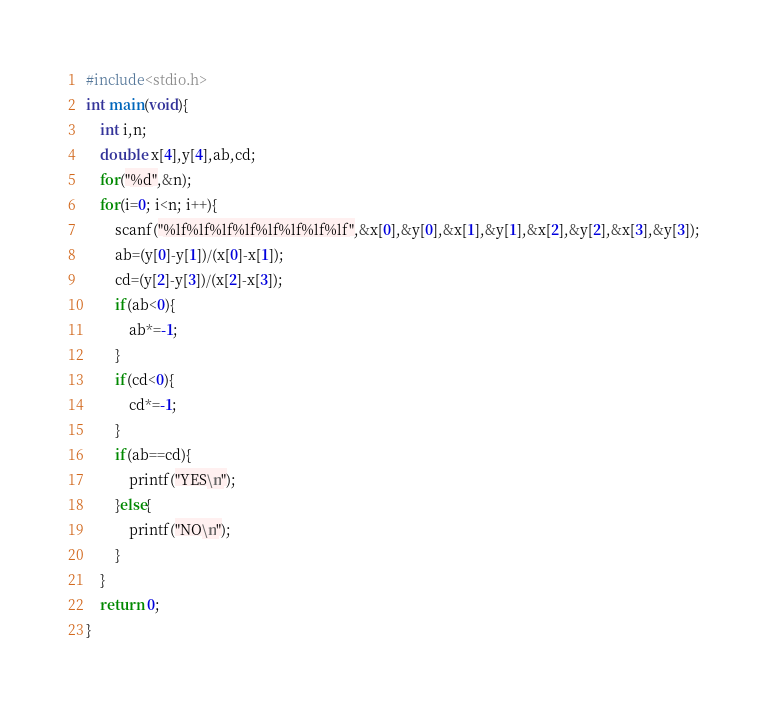Convert code to text. <code><loc_0><loc_0><loc_500><loc_500><_C_>#include<stdio.h>
int main(void){
    int i,n;
    double x[4],y[4],ab,cd;
    for("%d",&n);
    for(i=0; i<n; i++){
        scanf("%lf%lf%lf%lf%lf%lf%lf%lf",&x[0],&y[0],&x[1],&y[1],&x[2],&y[2],&x[3],&y[3]);
        ab=(y[0]-y[1])/(x[0]-x[1]);
        cd=(y[2]-y[3])/(x[2]-x[3]);
        if(ab<0){
            ab*=-1;
        }
        if(cd<0){
            cd*=-1;
        }
        if(ab==cd){
            printf("YES\n");
        }else{
            printf("NO\n");
        }
    }
    return 0;
}</code> 